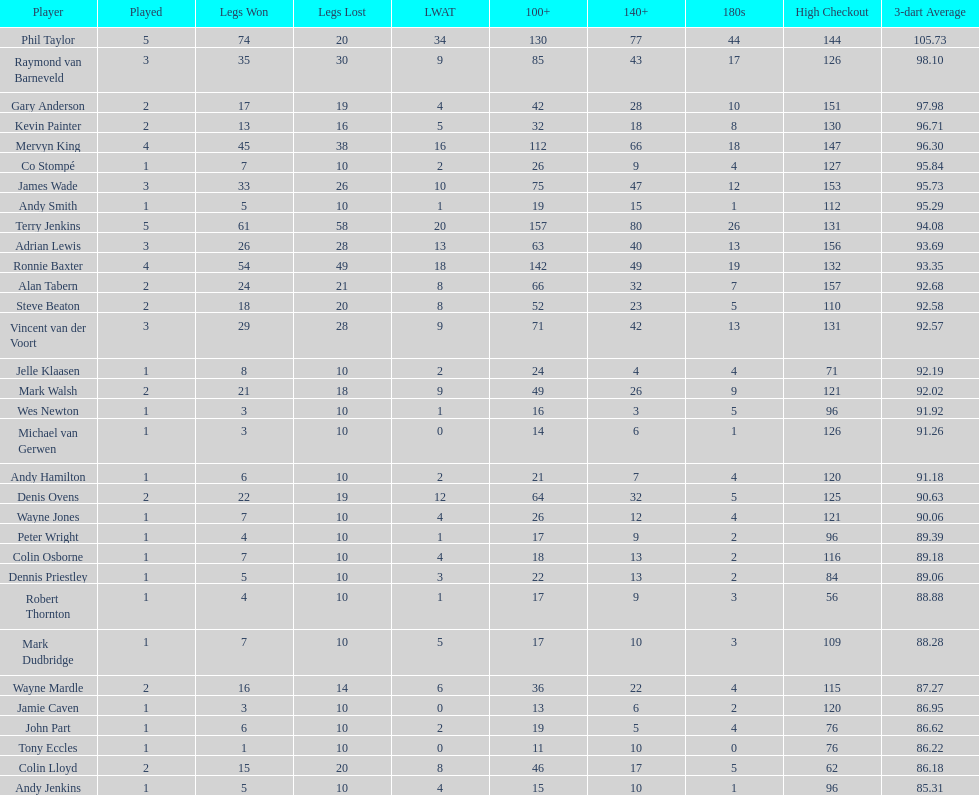Would you be able to parse every entry in this table? {'header': ['Player', 'Played', 'Legs Won', 'Legs Lost', 'LWAT', '100+', '140+', '180s', 'High Checkout', '3-dart Average'], 'rows': [['Phil Taylor', '5', '74', '20', '34', '130', '77', '44', '144', '105.73'], ['Raymond van Barneveld', '3', '35', '30', '9', '85', '43', '17', '126', '98.10'], ['Gary Anderson', '2', '17', '19', '4', '42', '28', '10', '151', '97.98'], ['Kevin Painter', '2', '13', '16', '5', '32', '18', '8', '130', '96.71'], ['Mervyn King', '4', '45', '38', '16', '112', '66', '18', '147', '96.30'], ['Co Stompé', '1', '7', '10', '2', '26', '9', '4', '127', '95.84'], ['James Wade', '3', '33', '26', '10', '75', '47', '12', '153', '95.73'], ['Andy Smith', '1', '5', '10', '1', '19', '15', '1', '112', '95.29'], ['Terry Jenkins', '5', '61', '58', '20', '157', '80', '26', '131', '94.08'], ['Adrian Lewis', '3', '26', '28', '13', '63', '40', '13', '156', '93.69'], ['Ronnie Baxter', '4', '54', '49', '18', '142', '49', '19', '132', '93.35'], ['Alan Tabern', '2', '24', '21', '8', '66', '32', '7', '157', '92.68'], ['Steve Beaton', '2', '18', '20', '8', '52', '23', '5', '110', '92.58'], ['Vincent van der Voort', '3', '29', '28', '9', '71', '42', '13', '131', '92.57'], ['Jelle Klaasen', '1', '8', '10', '2', '24', '4', '4', '71', '92.19'], ['Mark Walsh', '2', '21', '18', '9', '49', '26', '9', '121', '92.02'], ['Wes Newton', '1', '3', '10', '1', '16', '3', '5', '96', '91.92'], ['Michael van Gerwen', '1', '3', '10', '0', '14', '6', '1', '126', '91.26'], ['Andy Hamilton', '1', '6', '10', '2', '21', '7', '4', '120', '91.18'], ['Denis Ovens', '2', '22', '19', '12', '64', '32', '5', '125', '90.63'], ['Wayne Jones', '1', '7', '10', '4', '26', '12', '4', '121', '90.06'], ['Peter Wright', '1', '4', '10', '1', '17', '9', '2', '96', '89.39'], ['Colin Osborne', '1', '7', '10', '4', '18', '13', '2', '116', '89.18'], ['Dennis Priestley', '1', '5', '10', '3', '22', '13', '2', '84', '89.06'], ['Robert Thornton', '1', '4', '10', '1', '17', '9', '3', '56', '88.88'], ['Mark Dudbridge', '1', '7', '10', '5', '17', '10', '3', '109', '88.28'], ['Wayne Mardle', '2', '16', '14', '6', '36', '22', '4', '115', '87.27'], ['Jamie Caven', '1', '3', '10', '0', '13', '6', '2', '120', '86.95'], ['John Part', '1', '6', '10', '2', '19', '5', '4', '76', '86.62'], ['Tony Eccles', '1', '1', '10', '0', '11', '10', '0', '76', '86.22'], ['Colin Lloyd', '2', '15', '20', '8', '46', '17', '5', '62', '86.18'], ['Andy Jenkins', '1', '5', '10', '4', '15', '10', '1', '96', '85.31']]} Which player lost the least? Co Stompé, Andy Smith, Jelle Klaasen, Wes Newton, Michael van Gerwen, Andy Hamilton, Wayne Jones, Peter Wright, Colin Osborne, Dennis Priestley, Robert Thornton, Mark Dudbridge, Jamie Caven, John Part, Tony Eccles, Andy Jenkins. 